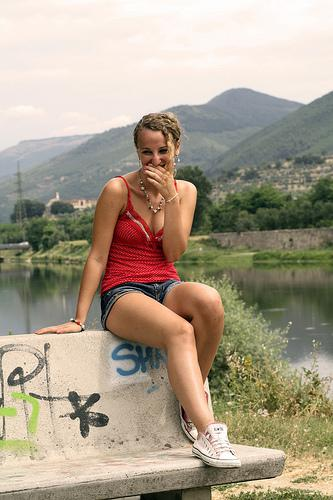Question: what is the girl doing?
Choices:
A. Standing.
B. Sitting.
C. Jumping up and down.
D. Laying down.
Answer with the letter. Answer: B Question: how many women?
Choices:
A. Two.
B. Zero.
C. Three.
D. One.
Answer with the letter. Answer: D Question: where is the woman?
Choices:
A. Standing next to a bench.
B. Sitting on a couch.
C. Laying down on a bench.
D. Sitting on a bench.
Answer with the letter. Answer: D Question: what color are her shoes?
Choices:
A. Black.
B. Brown.
C. Grey.
D. White.
Answer with the letter. Answer: D Question: who is laughing?
Choices:
A. The man.
B. The young girl.
C. The chimpanzee.
D. The woman.
Answer with the letter. Answer: D 